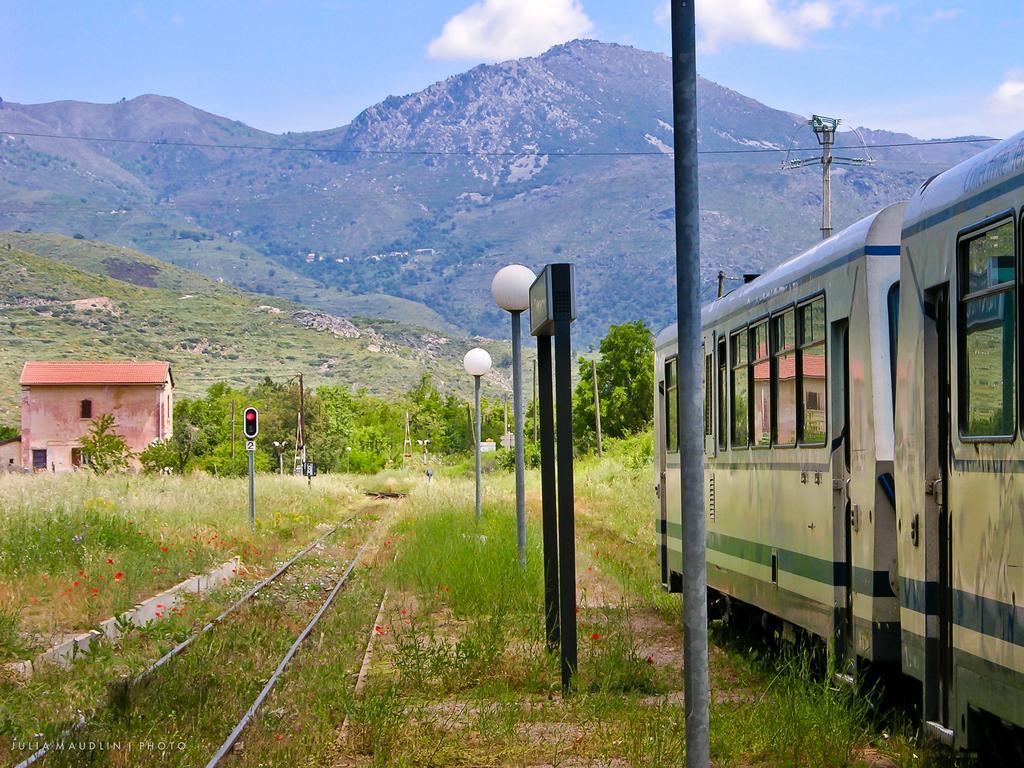Could you give a brief overview of what you see in this image? On the right side of the image we can see a train on the track and there are poles. We can see wires. On the left there is a shed and a traffic light. In the background there are trees, hills and sky. 